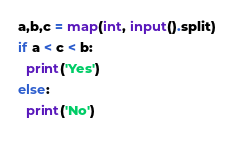<code> <loc_0><loc_0><loc_500><loc_500><_Python_>a,b,c = map(int, input().split)
if a < c < b:
  print('Yes')
else:
  print('No')</code> 